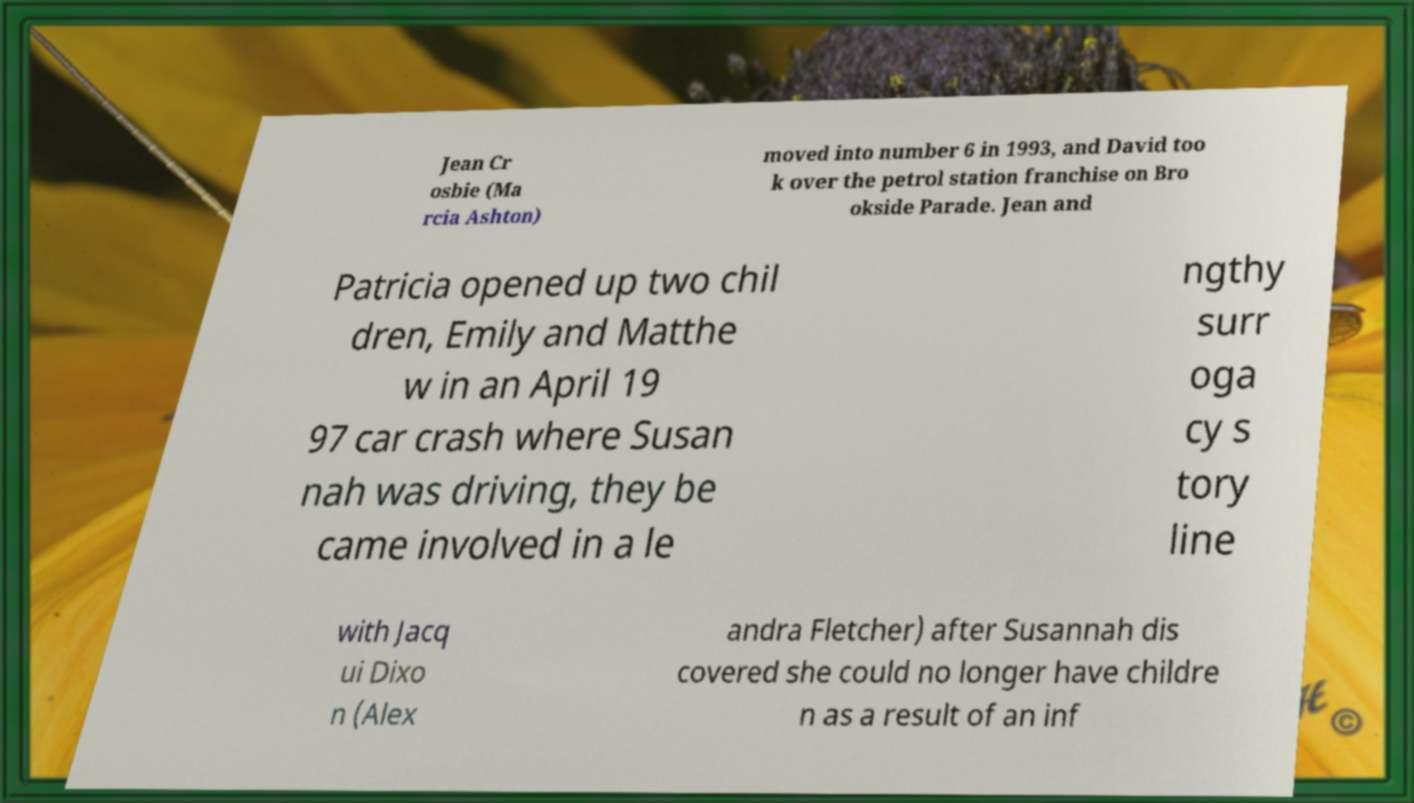I need the written content from this picture converted into text. Can you do that? Jean Cr osbie (Ma rcia Ashton) moved into number 6 in 1993, and David too k over the petrol station franchise on Bro okside Parade. Jean and Patricia opened up two chil dren, Emily and Matthe w in an April 19 97 car crash where Susan nah was driving, they be came involved in a le ngthy surr oga cy s tory line with Jacq ui Dixo n (Alex andra Fletcher) after Susannah dis covered she could no longer have childre n as a result of an inf 